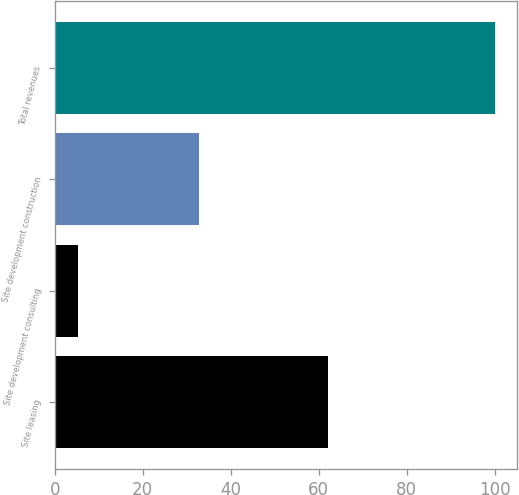Convert chart to OTSL. <chart><loc_0><loc_0><loc_500><loc_500><bar_chart><fcel>Site leasing<fcel>Site development consulting<fcel>Site development construction<fcel>Total revenues<nl><fcel>62<fcel>5.2<fcel>32.8<fcel>100<nl></chart> 